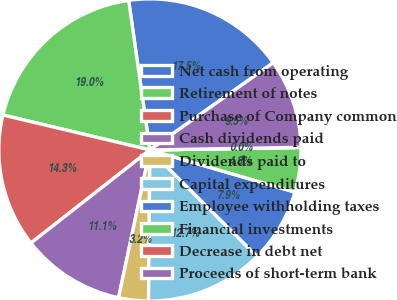Convert chart to OTSL. <chart><loc_0><loc_0><loc_500><loc_500><pie_chart><fcel>Net cash from operating<fcel>Retirement of notes<fcel>Purchase of Company common<fcel>Cash dividends paid<fcel>Dividends paid to<fcel>Capital expenditures<fcel>Employee withholding taxes<fcel>Financial investments<fcel>Decrease in debt net<fcel>Proceeds of short-term bank<nl><fcel>17.45%<fcel>19.04%<fcel>14.28%<fcel>11.11%<fcel>3.18%<fcel>12.7%<fcel>7.94%<fcel>4.77%<fcel>0.01%<fcel>9.52%<nl></chart> 